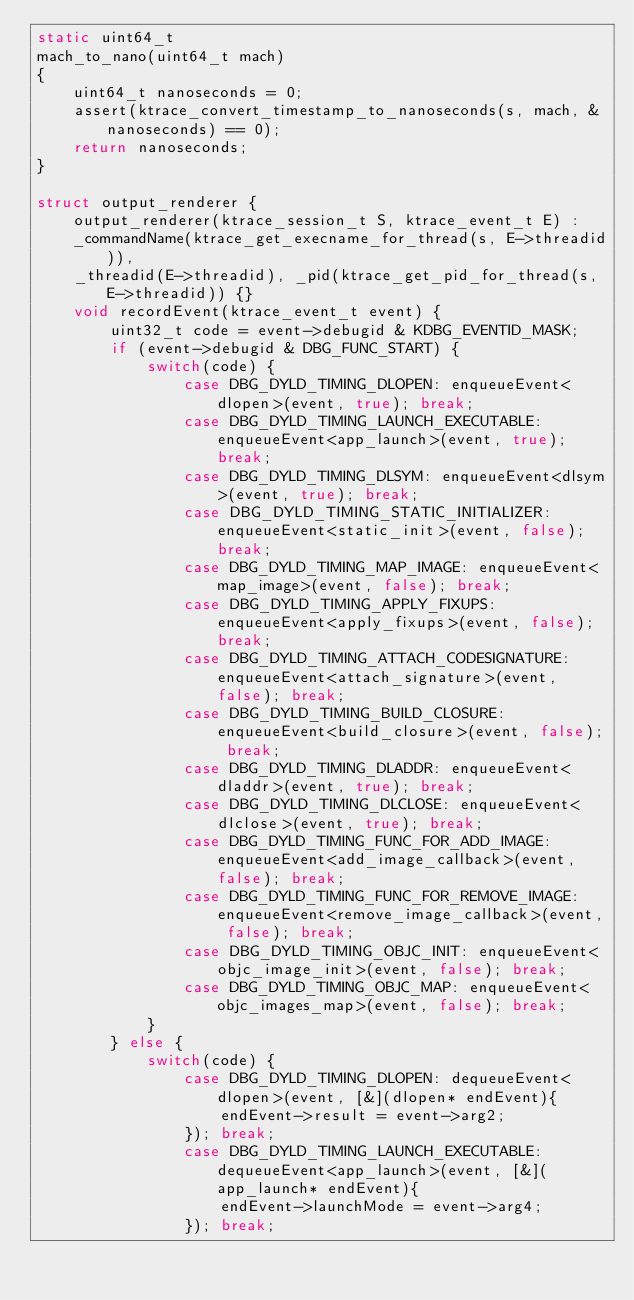Convert code to text. <code><loc_0><loc_0><loc_500><loc_500><_C++_>static uint64_t
mach_to_nano(uint64_t mach)
{
    uint64_t nanoseconds = 0;
    assert(ktrace_convert_timestamp_to_nanoseconds(s, mach, &nanoseconds) == 0);
    return nanoseconds;
}

struct output_renderer {
    output_renderer(ktrace_session_t S, ktrace_event_t E) :
    _commandName(ktrace_get_execname_for_thread(s, E->threadid)),
    _threadid(E->threadid), _pid(ktrace_get_pid_for_thread(s, E->threadid)) {}
    void recordEvent(ktrace_event_t event) {
        uint32_t code = event->debugid & KDBG_EVENTID_MASK;
        if (event->debugid & DBG_FUNC_START) {
            switch(code) {
                case DBG_DYLD_TIMING_DLOPEN: enqueueEvent<dlopen>(event, true); break;
                case DBG_DYLD_TIMING_LAUNCH_EXECUTABLE: enqueueEvent<app_launch>(event, true); break;
                case DBG_DYLD_TIMING_DLSYM: enqueueEvent<dlsym>(event, true); break;
                case DBG_DYLD_TIMING_STATIC_INITIALIZER: enqueueEvent<static_init>(event, false); break;
                case DBG_DYLD_TIMING_MAP_IMAGE: enqueueEvent<map_image>(event, false); break;
                case DBG_DYLD_TIMING_APPLY_FIXUPS: enqueueEvent<apply_fixups>(event, false); break;
                case DBG_DYLD_TIMING_ATTACH_CODESIGNATURE: enqueueEvent<attach_signature>(event, false); break;
                case DBG_DYLD_TIMING_BUILD_CLOSURE: enqueueEvent<build_closure>(event, false); break;
                case DBG_DYLD_TIMING_DLADDR: enqueueEvent<dladdr>(event, true); break;
                case DBG_DYLD_TIMING_DLCLOSE: enqueueEvent<dlclose>(event, true); break;
                case DBG_DYLD_TIMING_FUNC_FOR_ADD_IMAGE: enqueueEvent<add_image_callback>(event, false); break;
                case DBG_DYLD_TIMING_FUNC_FOR_REMOVE_IMAGE: enqueueEvent<remove_image_callback>(event, false); break;
                case DBG_DYLD_TIMING_OBJC_INIT: enqueueEvent<objc_image_init>(event, false); break;
                case DBG_DYLD_TIMING_OBJC_MAP: enqueueEvent<objc_images_map>(event, false); break;
            }
        } else {
            switch(code) {
                case DBG_DYLD_TIMING_DLOPEN: dequeueEvent<dlopen>(event, [&](dlopen* endEvent){
                    endEvent->result = event->arg2;
                }); break;
                case DBG_DYLD_TIMING_LAUNCH_EXECUTABLE: dequeueEvent<app_launch>(event, [&](app_launch* endEvent){
                    endEvent->launchMode = event->arg4;
                }); break;</code> 